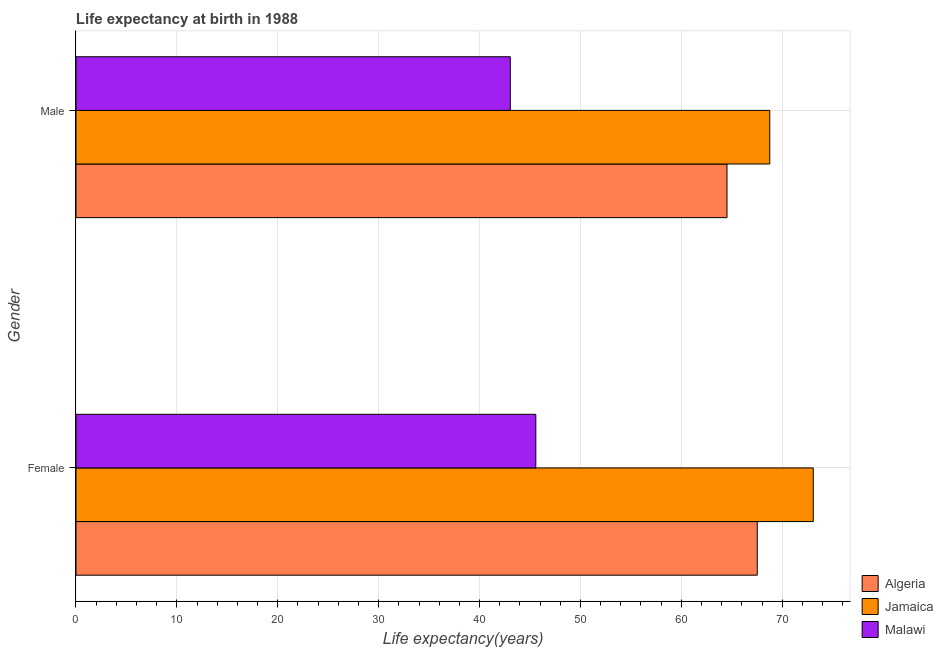Are the number of bars on each tick of the Y-axis equal?
Ensure brevity in your answer.  Yes. How many bars are there on the 1st tick from the bottom?
Your response must be concise. 3. What is the label of the 2nd group of bars from the top?
Give a very brief answer. Female. What is the life expectancy(female) in Jamaica?
Offer a terse response. 73.08. Across all countries, what is the maximum life expectancy(female)?
Your answer should be very brief. 73.08. Across all countries, what is the minimum life expectancy(female)?
Make the answer very short. 45.58. In which country was the life expectancy(male) maximum?
Your response must be concise. Jamaica. In which country was the life expectancy(female) minimum?
Your answer should be very brief. Malawi. What is the total life expectancy(female) in the graph?
Keep it short and to the point. 186.18. What is the difference between the life expectancy(female) in Malawi and that in Algeria?
Ensure brevity in your answer.  -21.95. What is the difference between the life expectancy(male) in Algeria and the life expectancy(female) in Jamaica?
Offer a very short reply. -8.55. What is the average life expectancy(female) per country?
Your response must be concise. 62.06. What is the difference between the life expectancy(male) and life expectancy(female) in Algeria?
Your answer should be compact. -3. In how many countries, is the life expectancy(female) greater than 38 years?
Ensure brevity in your answer.  3. What is the ratio of the life expectancy(male) in Algeria to that in Jamaica?
Your answer should be compact. 0.94. Is the life expectancy(male) in Algeria less than that in Malawi?
Your answer should be very brief. No. In how many countries, is the life expectancy(female) greater than the average life expectancy(female) taken over all countries?
Your answer should be very brief. 2. What does the 1st bar from the top in Female represents?
Offer a very short reply. Malawi. What does the 1st bar from the bottom in Male represents?
Keep it short and to the point. Algeria. Does the graph contain any zero values?
Provide a succinct answer. No. What is the title of the graph?
Your response must be concise. Life expectancy at birth in 1988. Does "Uruguay" appear as one of the legend labels in the graph?
Make the answer very short. No. What is the label or title of the X-axis?
Make the answer very short. Life expectancy(years). What is the label or title of the Y-axis?
Your response must be concise. Gender. What is the Life expectancy(years) in Algeria in Female?
Provide a succinct answer. 67.53. What is the Life expectancy(years) in Jamaica in Female?
Provide a short and direct response. 73.08. What is the Life expectancy(years) in Malawi in Female?
Offer a terse response. 45.58. What is the Life expectancy(years) in Algeria in Male?
Give a very brief answer. 64.53. What is the Life expectancy(years) in Jamaica in Male?
Ensure brevity in your answer.  68.77. What is the Life expectancy(years) in Malawi in Male?
Make the answer very short. 43.05. Across all Gender, what is the maximum Life expectancy(years) in Algeria?
Make the answer very short. 67.53. Across all Gender, what is the maximum Life expectancy(years) in Jamaica?
Your answer should be compact. 73.08. Across all Gender, what is the maximum Life expectancy(years) in Malawi?
Give a very brief answer. 45.58. Across all Gender, what is the minimum Life expectancy(years) in Algeria?
Your answer should be compact. 64.53. Across all Gender, what is the minimum Life expectancy(years) in Jamaica?
Keep it short and to the point. 68.77. Across all Gender, what is the minimum Life expectancy(years) of Malawi?
Make the answer very short. 43.05. What is the total Life expectancy(years) of Algeria in the graph?
Your response must be concise. 132.05. What is the total Life expectancy(years) in Jamaica in the graph?
Your response must be concise. 141.84. What is the total Life expectancy(years) of Malawi in the graph?
Offer a terse response. 88.62. What is the difference between the Life expectancy(years) of Algeria in Female and that in Male?
Offer a very short reply. 3. What is the difference between the Life expectancy(years) of Jamaica in Female and that in Male?
Ensure brevity in your answer.  4.31. What is the difference between the Life expectancy(years) of Malawi in Female and that in Male?
Ensure brevity in your answer.  2.53. What is the difference between the Life expectancy(years) of Algeria in Female and the Life expectancy(years) of Jamaica in Male?
Provide a short and direct response. -1.24. What is the difference between the Life expectancy(years) in Algeria in Female and the Life expectancy(years) in Malawi in Male?
Your response must be concise. 24.48. What is the difference between the Life expectancy(years) in Jamaica in Female and the Life expectancy(years) in Malawi in Male?
Make the answer very short. 30.03. What is the average Life expectancy(years) of Algeria per Gender?
Ensure brevity in your answer.  66.03. What is the average Life expectancy(years) in Jamaica per Gender?
Offer a terse response. 70.92. What is the average Life expectancy(years) of Malawi per Gender?
Offer a terse response. 44.31. What is the difference between the Life expectancy(years) of Algeria and Life expectancy(years) of Jamaica in Female?
Provide a succinct answer. -5.55. What is the difference between the Life expectancy(years) in Algeria and Life expectancy(years) in Malawi in Female?
Your response must be concise. 21.95. What is the difference between the Life expectancy(years) of Jamaica and Life expectancy(years) of Malawi in Female?
Your response must be concise. 27.5. What is the difference between the Life expectancy(years) of Algeria and Life expectancy(years) of Jamaica in Male?
Offer a terse response. -4.24. What is the difference between the Life expectancy(years) of Algeria and Life expectancy(years) of Malawi in Male?
Offer a terse response. 21.48. What is the difference between the Life expectancy(years) in Jamaica and Life expectancy(years) in Malawi in Male?
Make the answer very short. 25.72. What is the ratio of the Life expectancy(years) in Algeria in Female to that in Male?
Make the answer very short. 1.05. What is the ratio of the Life expectancy(years) of Jamaica in Female to that in Male?
Offer a very short reply. 1.06. What is the ratio of the Life expectancy(years) in Malawi in Female to that in Male?
Make the answer very short. 1.06. What is the difference between the highest and the second highest Life expectancy(years) of Algeria?
Your answer should be very brief. 3. What is the difference between the highest and the second highest Life expectancy(years) in Jamaica?
Make the answer very short. 4.31. What is the difference between the highest and the second highest Life expectancy(years) of Malawi?
Give a very brief answer. 2.53. What is the difference between the highest and the lowest Life expectancy(years) in Algeria?
Ensure brevity in your answer.  3. What is the difference between the highest and the lowest Life expectancy(years) in Jamaica?
Provide a short and direct response. 4.31. What is the difference between the highest and the lowest Life expectancy(years) of Malawi?
Your answer should be compact. 2.53. 